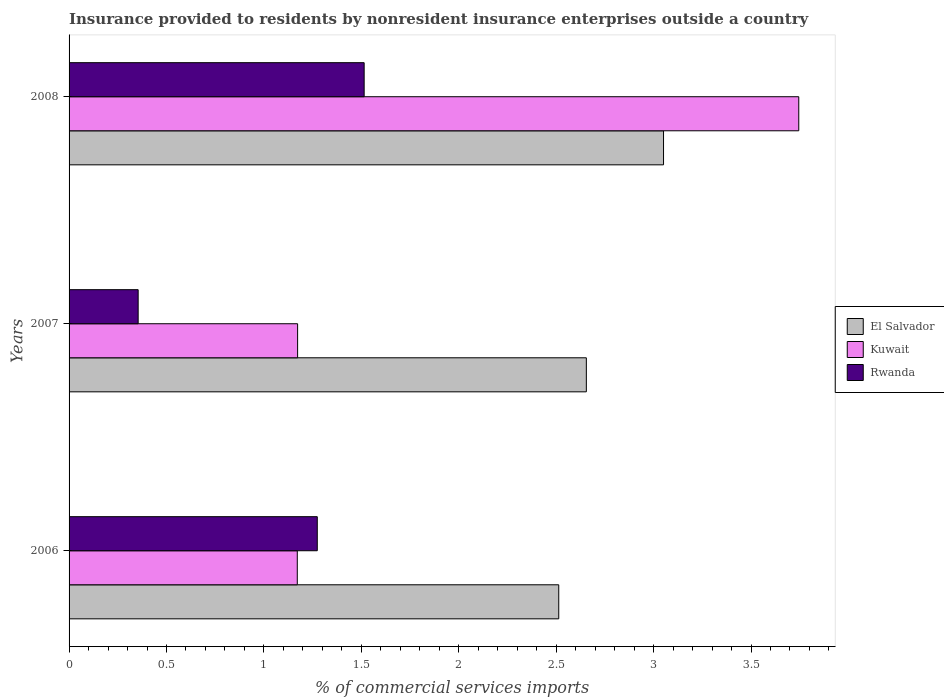How many different coloured bars are there?
Make the answer very short. 3. Are the number of bars per tick equal to the number of legend labels?
Give a very brief answer. Yes. Are the number of bars on each tick of the Y-axis equal?
Offer a terse response. Yes. What is the label of the 3rd group of bars from the top?
Offer a terse response. 2006. In how many cases, is the number of bars for a given year not equal to the number of legend labels?
Offer a terse response. 0. What is the Insurance provided to residents in El Salvador in 2006?
Provide a succinct answer. 2.51. Across all years, what is the maximum Insurance provided to residents in Rwanda?
Give a very brief answer. 1.51. Across all years, what is the minimum Insurance provided to residents in Rwanda?
Your response must be concise. 0.35. What is the total Insurance provided to residents in Kuwait in the graph?
Ensure brevity in your answer.  6.09. What is the difference between the Insurance provided to residents in Kuwait in 2007 and that in 2008?
Provide a succinct answer. -2.57. What is the difference between the Insurance provided to residents in El Salvador in 2006 and the Insurance provided to residents in Rwanda in 2007?
Provide a succinct answer. 2.16. What is the average Insurance provided to residents in Kuwait per year?
Provide a short and direct response. 2.03. In the year 2006, what is the difference between the Insurance provided to residents in Rwanda and Insurance provided to residents in Kuwait?
Keep it short and to the point. 0.1. What is the ratio of the Insurance provided to residents in Kuwait in 2006 to that in 2008?
Offer a terse response. 0.31. What is the difference between the highest and the second highest Insurance provided to residents in Kuwait?
Offer a very short reply. 2.57. What is the difference between the highest and the lowest Insurance provided to residents in Kuwait?
Keep it short and to the point. 2.57. Is the sum of the Insurance provided to residents in Kuwait in 2006 and 2008 greater than the maximum Insurance provided to residents in El Salvador across all years?
Your response must be concise. Yes. What does the 2nd bar from the top in 2007 represents?
Your answer should be compact. Kuwait. What does the 2nd bar from the bottom in 2007 represents?
Keep it short and to the point. Kuwait. How many bars are there?
Your answer should be compact. 9. Are all the bars in the graph horizontal?
Offer a terse response. Yes. Does the graph contain any zero values?
Offer a terse response. No. How many legend labels are there?
Offer a very short reply. 3. What is the title of the graph?
Make the answer very short. Insurance provided to residents by nonresident insurance enterprises outside a country. Does "High income: OECD" appear as one of the legend labels in the graph?
Ensure brevity in your answer.  No. What is the label or title of the X-axis?
Make the answer very short. % of commercial services imports. What is the % of commercial services imports in El Salvador in 2006?
Provide a short and direct response. 2.51. What is the % of commercial services imports of Kuwait in 2006?
Provide a succinct answer. 1.17. What is the % of commercial services imports of Rwanda in 2006?
Give a very brief answer. 1.27. What is the % of commercial services imports of El Salvador in 2007?
Make the answer very short. 2.65. What is the % of commercial services imports in Kuwait in 2007?
Keep it short and to the point. 1.17. What is the % of commercial services imports of Rwanda in 2007?
Keep it short and to the point. 0.35. What is the % of commercial services imports in El Salvador in 2008?
Your response must be concise. 3.05. What is the % of commercial services imports of Kuwait in 2008?
Make the answer very short. 3.75. What is the % of commercial services imports in Rwanda in 2008?
Your answer should be very brief. 1.51. Across all years, what is the maximum % of commercial services imports in El Salvador?
Provide a succinct answer. 3.05. Across all years, what is the maximum % of commercial services imports in Kuwait?
Give a very brief answer. 3.75. Across all years, what is the maximum % of commercial services imports of Rwanda?
Your response must be concise. 1.51. Across all years, what is the minimum % of commercial services imports in El Salvador?
Offer a terse response. 2.51. Across all years, what is the minimum % of commercial services imports in Kuwait?
Provide a short and direct response. 1.17. Across all years, what is the minimum % of commercial services imports of Rwanda?
Give a very brief answer. 0.35. What is the total % of commercial services imports in El Salvador in the graph?
Offer a very short reply. 8.22. What is the total % of commercial services imports of Kuwait in the graph?
Give a very brief answer. 6.09. What is the total % of commercial services imports of Rwanda in the graph?
Make the answer very short. 3.14. What is the difference between the % of commercial services imports in El Salvador in 2006 and that in 2007?
Your response must be concise. -0.14. What is the difference between the % of commercial services imports in Kuwait in 2006 and that in 2007?
Offer a very short reply. -0. What is the difference between the % of commercial services imports of Rwanda in 2006 and that in 2007?
Your answer should be compact. 0.92. What is the difference between the % of commercial services imports of El Salvador in 2006 and that in 2008?
Your response must be concise. -0.54. What is the difference between the % of commercial services imports in Kuwait in 2006 and that in 2008?
Ensure brevity in your answer.  -2.57. What is the difference between the % of commercial services imports of Rwanda in 2006 and that in 2008?
Your answer should be very brief. -0.24. What is the difference between the % of commercial services imports in El Salvador in 2007 and that in 2008?
Offer a terse response. -0.4. What is the difference between the % of commercial services imports of Kuwait in 2007 and that in 2008?
Provide a short and direct response. -2.57. What is the difference between the % of commercial services imports of Rwanda in 2007 and that in 2008?
Provide a short and direct response. -1.16. What is the difference between the % of commercial services imports in El Salvador in 2006 and the % of commercial services imports in Kuwait in 2007?
Keep it short and to the point. 1.34. What is the difference between the % of commercial services imports in El Salvador in 2006 and the % of commercial services imports in Rwanda in 2007?
Make the answer very short. 2.16. What is the difference between the % of commercial services imports in Kuwait in 2006 and the % of commercial services imports in Rwanda in 2007?
Your answer should be very brief. 0.82. What is the difference between the % of commercial services imports in El Salvador in 2006 and the % of commercial services imports in Kuwait in 2008?
Your answer should be compact. -1.23. What is the difference between the % of commercial services imports in El Salvador in 2006 and the % of commercial services imports in Rwanda in 2008?
Keep it short and to the point. 1. What is the difference between the % of commercial services imports of Kuwait in 2006 and the % of commercial services imports of Rwanda in 2008?
Make the answer very short. -0.34. What is the difference between the % of commercial services imports in El Salvador in 2007 and the % of commercial services imports in Kuwait in 2008?
Provide a succinct answer. -1.09. What is the difference between the % of commercial services imports in El Salvador in 2007 and the % of commercial services imports in Rwanda in 2008?
Make the answer very short. 1.14. What is the difference between the % of commercial services imports in Kuwait in 2007 and the % of commercial services imports in Rwanda in 2008?
Your answer should be very brief. -0.34. What is the average % of commercial services imports of El Salvador per year?
Provide a short and direct response. 2.74. What is the average % of commercial services imports in Kuwait per year?
Keep it short and to the point. 2.03. What is the average % of commercial services imports in Rwanda per year?
Give a very brief answer. 1.05. In the year 2006, what is the difference between the % of commercial services imports of El Salvador and % of commercial services imports of Kuwait?
Make the answer very short. 1.34. In the year 2006, what is the difference between the % of commercial services imports of El Salvador and % of commercial services imports of Rwanda?
Offer a terse response. 1.24. In the year 2006, what is the difference between the % of commercial services imports in Kuwait and % of commercial services imports in Rwanda?
Your answer should be very brief. -0.1. In the year 2007, what is the difference between the % of commercial services imports in El Salvador and % of commercial services imports in Kuwait?
Provide a succinct answer. 1.48. In the year 2007, what is the difference between the % of commercial services imports in El Salvador and % of commercial services imports in Rwanda?
Offer a terse response. 2.3. In the year 2007, what is the difference between the % of commercial services imports in Kuwait and % of commercial services imports in Rwanda?
Keep it short and to the point. 0.82. In the year 2008, what is the difference between the % of commercial services imports of El Salvador and % of commercial services imports of Kuwait?
Your response must be concise. -0.69. In the year 2008, what is the difference between the % of commercial services imports in El Salvador and % of commercial services imports in Rwanda?
Provide a short and direct response. 1.54. In the year 2008, what is the difference between the % of commercial services imports in Kuwait and % of commercial services imports in Rwanda?
Keep it short and to the point. 2.23. What is the ratio of the % of commercial services imports in El Salvador in 2006 to that in 2007?
Offer a very short reply. 0.95. What is the ratio of the % of commercial services imports of Kuwait in 2006 to that in 2007?
Offer a very short reply. 1. What is the ratio of the % of commercial services imports of Rwanda in 2006 to that in 2007?
Offer a very short reply. 3.59. What is the ratio of the % of commercial services imports in El Salvador in 2006 to that in 2008?
Provide a short and direct response. 0.82. What is the ratio of the % of commercial services imports of Kuwait in 2006 to that in 2008?
Provide a succinct answer. 0.31. What is the ratio of the % of commercial services imports of Rwanda in 2006 to that in 2008?
Provide a succinct answer. 0.84. What is the ratio of the % of commercial services imports in El Salvador in 2007 to that in 2008?
Give a very brief answer. 0.87. What is the ratio of the % of commercial services imports of Kuwait in 2007 to that in 2008?
Offer a terse response. 0.31. What is the ratio of the % of commercial services imports in Rwanda in 2007 to that in 2008?
Provide a short and direct response. 0.23. What is the difference between the highest and the second highest % of commercial services imports in El Salvador?
Make the answer very short. 0.4. What is the difference between the highest and the second highest % of commercial services imports of Kuwait?
Your answer should be very brief. 2.57. What is the difference between the highest and the second highest % of commercial services imports of Rwanda?
Your response must be concise. 0.24. What is the difference between the highest and the lowest % of commercial services imports of El Salvador?
Your answer should be compact. 0.54. What is the difference between the highest and the lowest % of commercial services imports of Kuwait?
Offer a very short reply. 2.57. What is the difference between the highest and the lowest % of commercial services imports of Rwanda?
Make the answer very short. 1.16. 